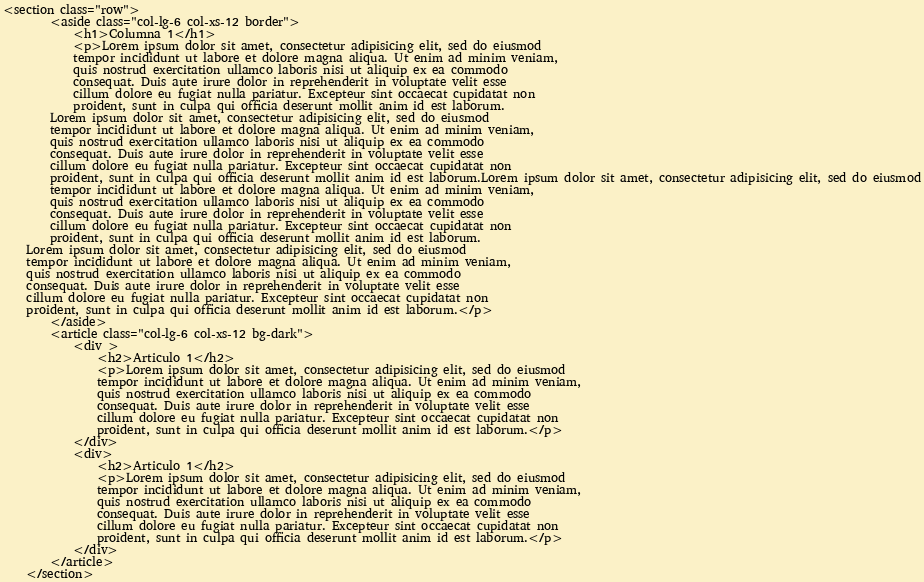<code> <loc_0><loc_0><loc_500><loc_500><_PHP_><section class="row">
		<aside class="col-lg-6 col-xs-12 border">
			<h1>Columna 1</h1>
			<p>Lorem ipsum dolor sit amet, consectetur adipisicing elit, sed do eiusmod
			tempor incididunt ut labore et dolore magna aliqua. Ut enim ad minim veniam,
			quis nostrud exercitation ullamco laboris nisi ut aliquip ex ea commodo
			consequat. Duis aute irure dolor in reprehenderit in voluptate velit esse
			cillum dolore eu fugiat nulla pariatur. Excepteur sint occaecat cupidatat non
			proident, sunt in culpa qui officia deserunt mollit anim id est laborum.
		Lorem ipsum dolor sit amet, consectetur adipisicing elit, sed do eiusmod
		tempor incididunt ut labore et dolore magna aliqua. Ut enim ad minim veniam,
		quis nostrud exercitation ullamco laboris nisi ut aliquip ex ea commodo
		consequat. Duis aute irure dolor in reprehenderit in voluptate velit esse
		cillum dolore eu fugiat nulla pariatur. Excepteur sint occaecat cupidatat non
		proident, sunt in culpa qui officia deserunt mollit anim id est laborum.Lorem ipsum dolor sit amet, consectetur adipisicing elit, sed do eiusmod
		tempor incididunt ut labore et dolore magna aliqua. Ut enim ad minim veniam,
		quis nostrud exercitation ullamco laboris nisi ut aliquip ex ea commodo
		consequat. Duis aute irure dolor in reprehenderit in voluptate velit esse
		cillum dolore eu fugiat nulla pariatur. Excepteur sint occaecat cupidatat non
		proident, sunt in culpa qui officia deserunt mollit anim id est laborum.
	Lorem ipsum dolor sit amet, consectetur adipisicing elit, sed do eiusmod
	tempor incididunt ut labore et dolore magna aliqua. Ut enim ad minim veniam,
	quis nostrud exercitation ullamco laboris nisi ut aliquip ex ea commodo
	consequat. Duis aute irure dolor in reprehenderit in voluptate velit esse
	cillum dolore eu fugiat nulla pariatur. Excepteur sint occaecat cupidatat non
	proident, sunt in culpa qui officia deserunt mollit anim id est laborum.</p>
		</aside>
		<article class="col-lg-6 col-xs-12 bg-dark">
			<div >
				<h2>Articulo 1</h2>
				<p>Lorem ipsum dolor sit amet, consectetur adipisicing elit, sed do eiusmod
				tempor incididunt ut labore et dolore magna aliqua. Ut enim ad minim veniam,
				quis nostrud exercitation ullamco laboris nisi ut aliquip ex ea commodo
				consequat. Duis aute irure dolor in reprehenderit in voluptate velit esse
				cillum dolore eu fugiat nulla pariatur. Excepteur sint occaecat cupidatat non
				proident, sunt in culpa qui officia deserunt mollit anim id est laborum.</p>
			</div>
			<div>
				<h2>Articulo 1</h2>
				<p>Lorem ipsum dolor sit amet, consectetur adipisicing elit, sed do eiusmod
				tempor incididunt ut labore et dolore magna aliqua. Ut enim ad minim veniam,
				quis nostrud exercitation ullamco laboris nisi ut aliquip ex ea commodo
				consequat. Duis aute irure dolor in reprehenderit in voluptate velit esse
				cillum dolore eu fugiat nulla pariatur. Excepteur sint occaecat cupidatat non
				proident, sunt in culpa qui officia deserunt mollit anim id est laborum.</p>
			</div>
		</article>
	</section></code> 